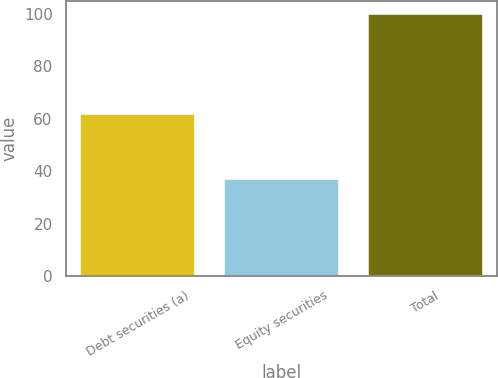Convert chart to OTSL. <chart><loc_0><loc_0><loc_500><loc_500><bar_chart><fcel>Debt securities (a)<fcel>Equity securities<fcel>Total<nl><fcel>62<fcel>37<fcel>100<nl></chart> 